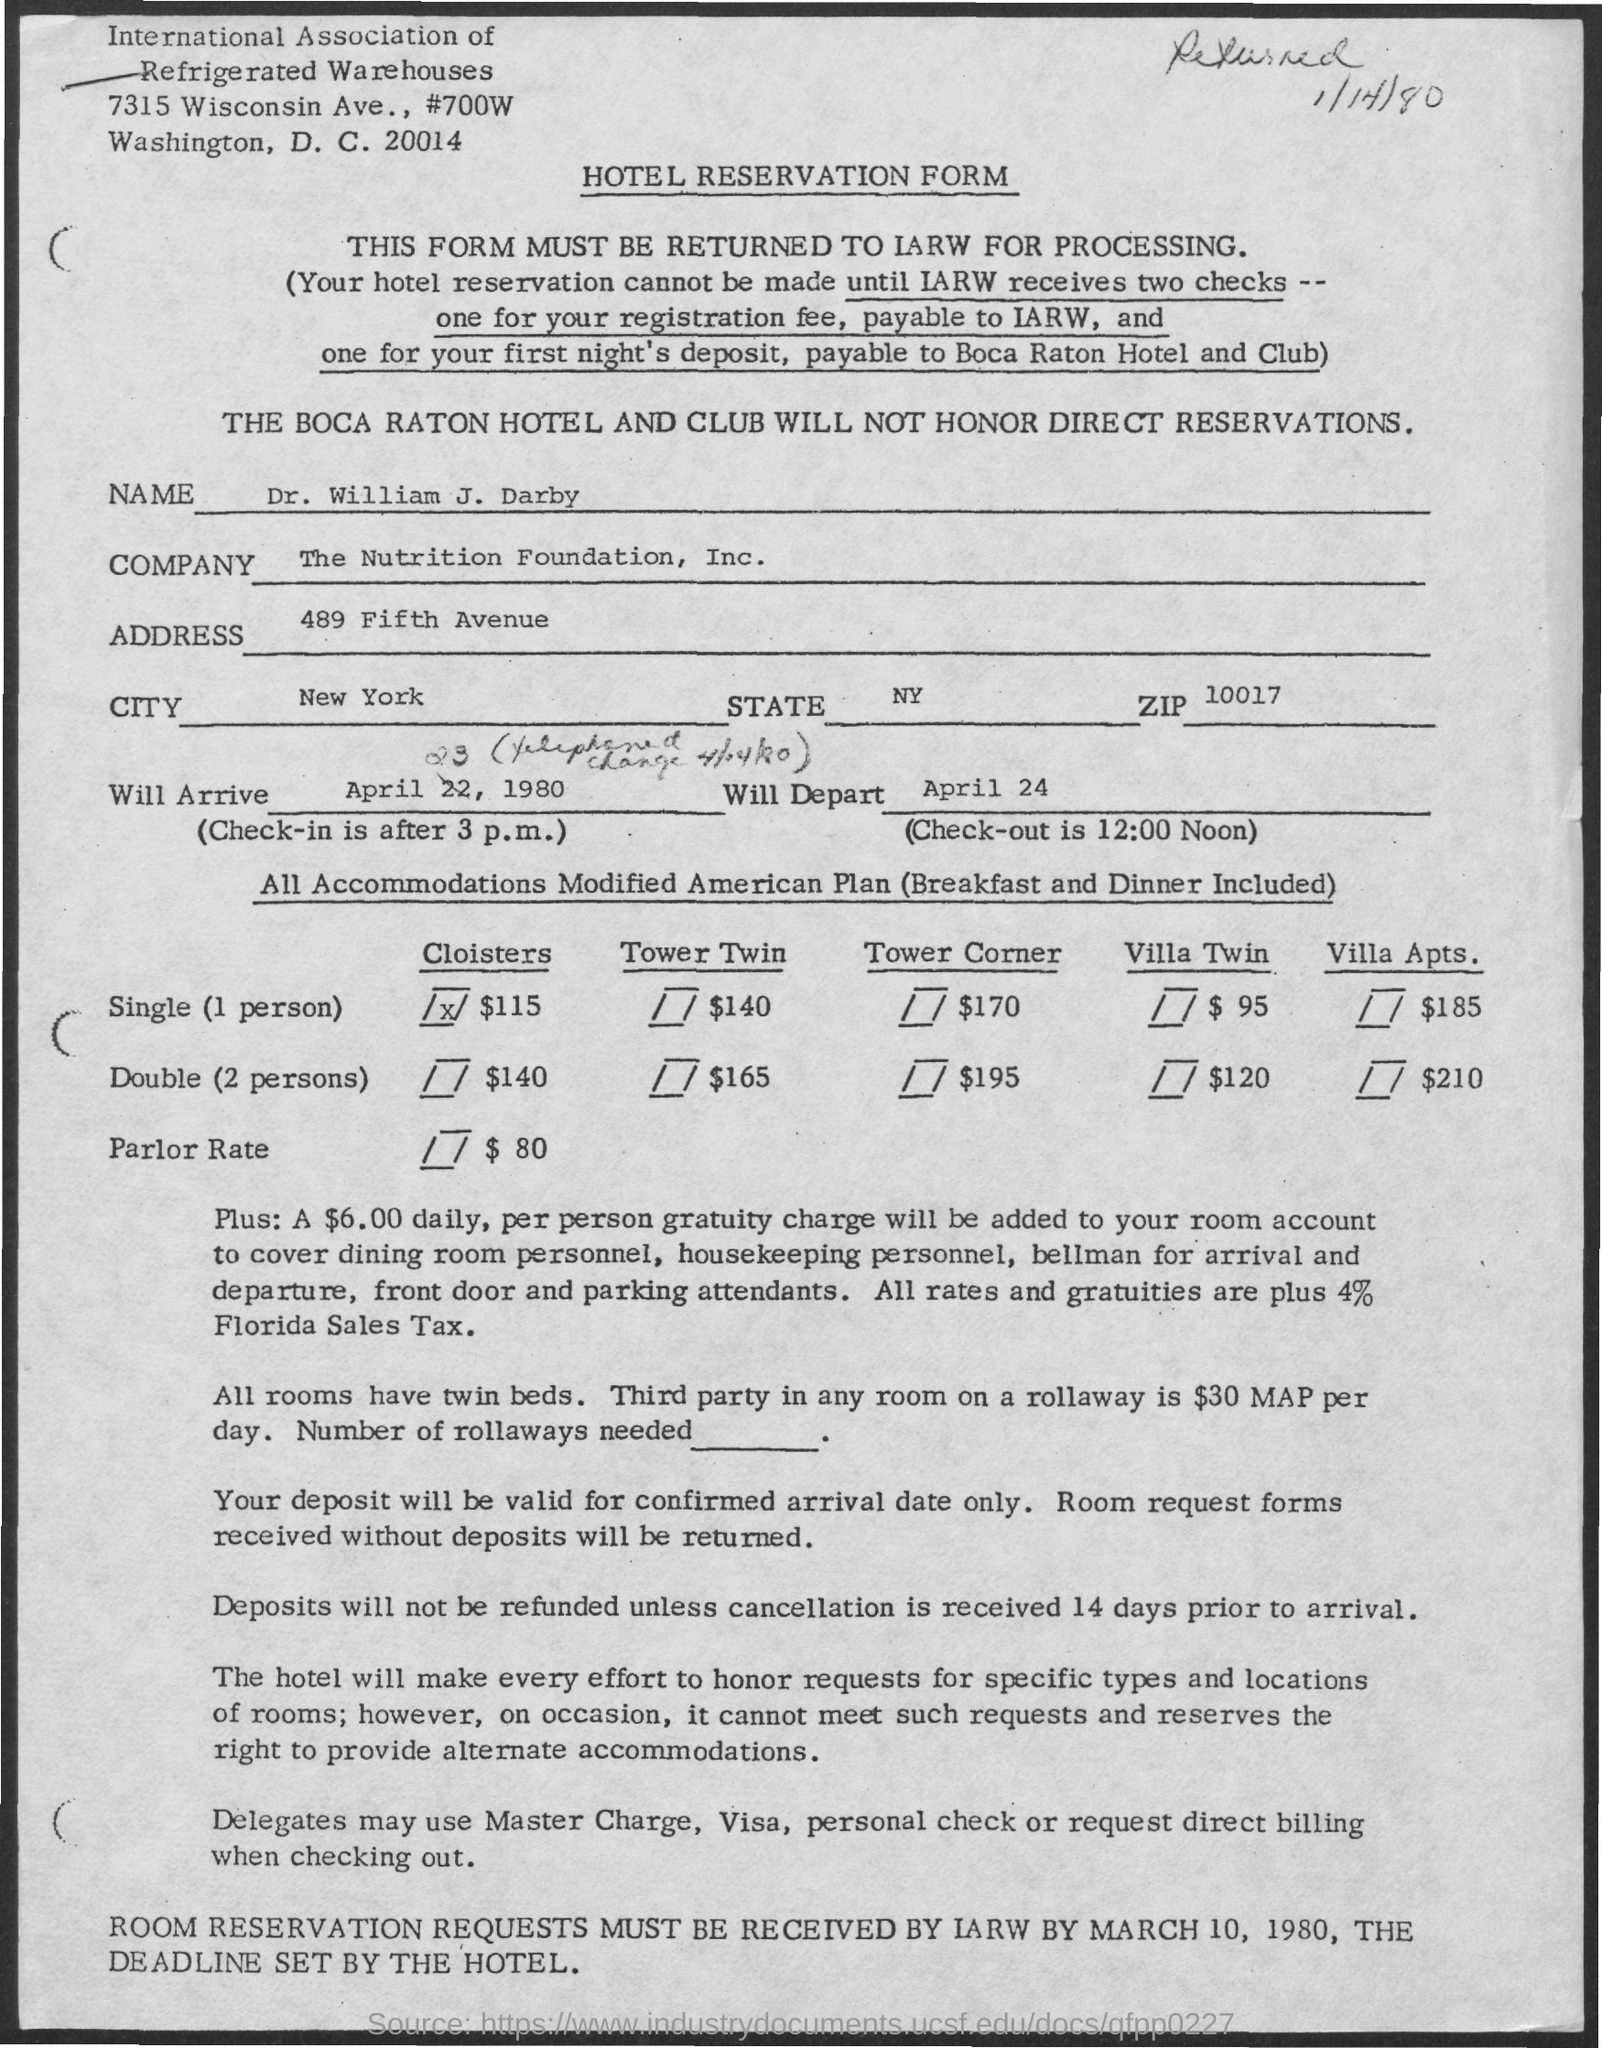What is the City? The document in the image is a hotel reservation form which lists the address of the individual making the reservation as 'New York'. Hence, the city related to the context of the question is New York City. 